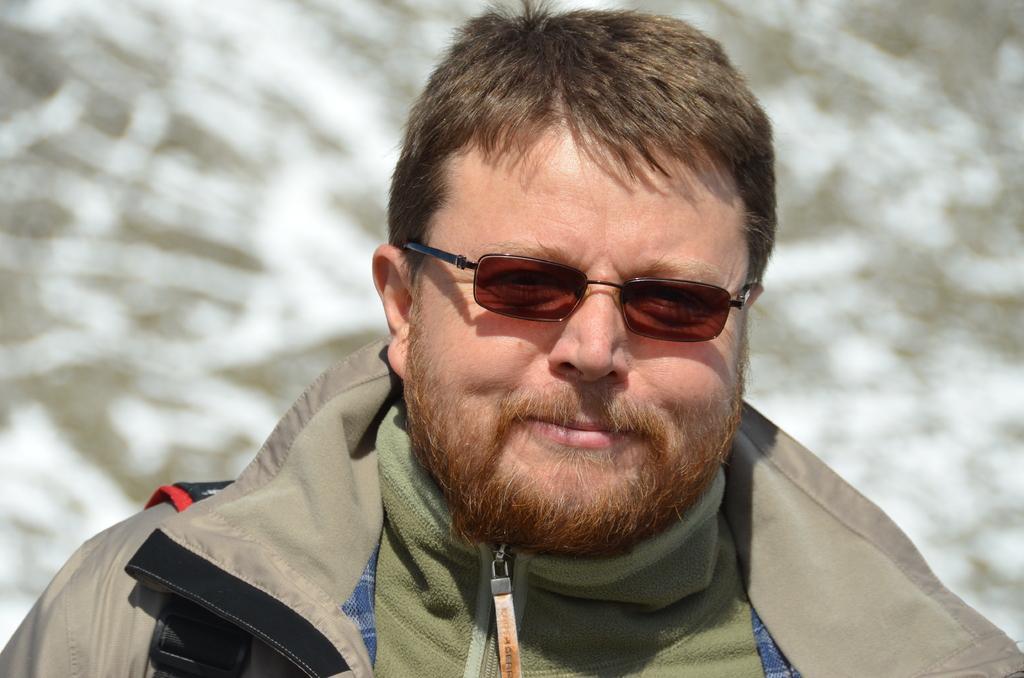Describe this image in one or two sentences. This image is taken outdoors. In this image the background is a little blurred. In the middle of the image there is a man with a smiling face. 